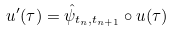<formula> <loc_0><loc_0><loc_500><loc_500>u ^ { \prime } ( \tau ) = \hat { \psi } _ { t _ { n } , t _ { n + 1 } } \circ u ( \tau )</formula> 